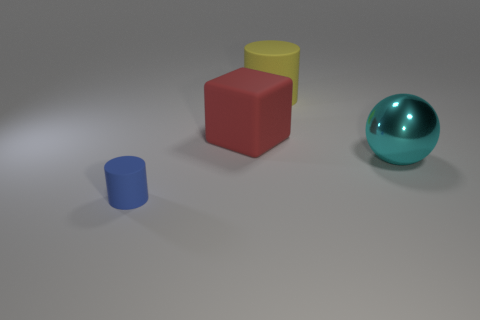Add 1 big red things. How many objects exist? 5 Subtract all spheres. How many objects are left? 3 Add 1 big balls. How many big balls exist? 2 Subtract 0 yellow spheres. How many objects are left? 4 Subtract all blue things. Subtract all matte blocks. How many objects are left? 2 Add 1 big red matte objects. How many big red matte objects are left? 2 